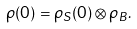Convert formula to latex. <formula><loc_0><loc_0><loc_500><loc_500>\rho ( 0 ) = \rho _ { S } ( 0 ) \otimes \rho _ { B } .</formula> 